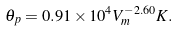<formula> <loc_0><loc_0><loc_500><loc_500>\theta _ { p } = { 0 . 9 1 \times 1 0 ^ { 4 } } { V _ { m } ^ { - 2 . 6 0 } } K .</formula> 